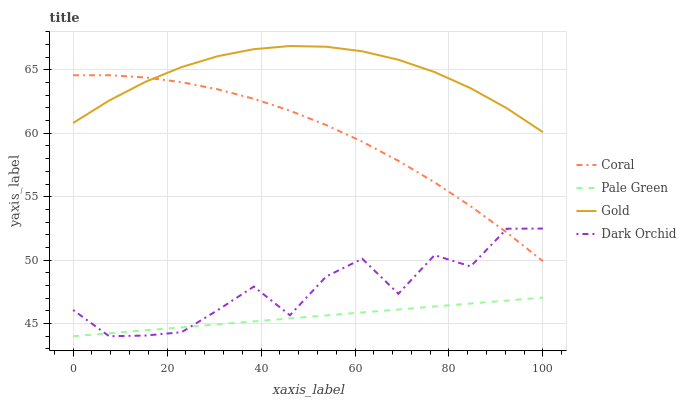Does Pale Green have the minimum area under the curve?
Answer yes or no. Yes. Does Gold have the maximum area under the curve?
Answer yes or no. Yes. Does Dark Orchid have the minimum area under the curve?
Answer yes or no. No. Does Dark Orchid have the maximum area under the curve?
Answer yes or no. No. Is Pale Green the smoothest?
Answer yes or no. Yes. Is Dark Orchid the roughest?
Answer yes or no. Yes. Is Dark Orchid the smoothest?
Answer yes or no. No. Is Pale Green the roughest?
Answer yes or no. No. Does Pale Green have the lowest value?
Answer yes or no. Yes. Does Gold have the lowest value?
Answer yes or no. No. Does Gold have the highest value?
Answer yes or no. Yes. Does Dark Orchid have the highest value?
Answer yes or no. No. Is Pale Green less than Coral?
Answer yes or no. Yes. Is Gold greater than Dark Orchid?
Answer yes or no. Yes. Does Coral intersect Gold?
Answer yes or no. Yes. Is Coral less than Gold?
Answer yes or no. No. Is Coral greater than Gold?
Answer yes or no. No. Does Pale Green intersect Coral?
Answer yes or no. No. 